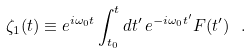Convert formula to latex. <formula><loc_0><loc_0><loc_500><loc_500>\zeta _ { 1 } ( t ) \equiv e ^ { i \omega _ { 0 } t } \int _ { t _ { 0 } } ^ { t } d t ^ { \prime } \, e ^ { - i \omega _ { 0 } t ^ { \prime } } F ( t ^ { \prime } ) \ .</formula> 